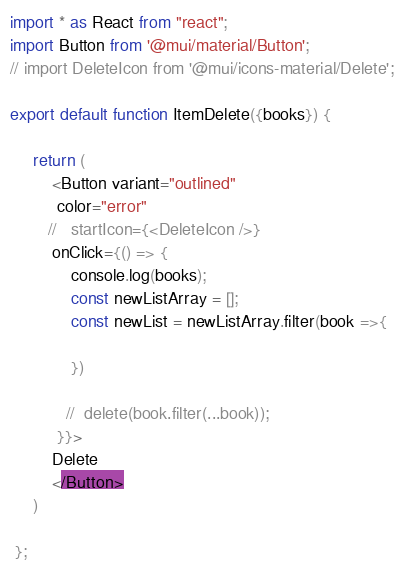Convert code to text. <code><loc_0><loc_0><loc_500><loc_500><_JavaScript_>import * as React from "react";
import Button from '@mui/material/Button';
// import DeleteIcon from '@mui/icons-material/Delete';

export default function ItemDelete({books}) {

     return (
         <Button variant="outlined"
          color="error" 
        //   startIcon={<DeleteIcon />}
         onClick={() => {
             console.log(books);
             const newListArray = [];
             const newList = newListArray.filter(book =>{

             })
            
            //  delete(book.filter(...book));
          }}>
         Delete 
         </Button>
     )

 };</code> 